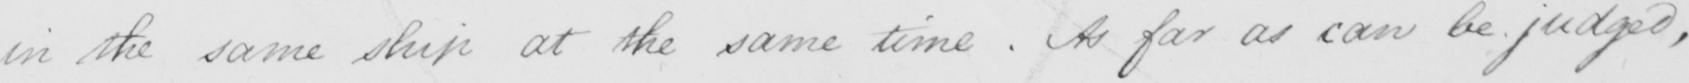What does this handwritten line say? in the same ship at the same time . As far as can be judged , 